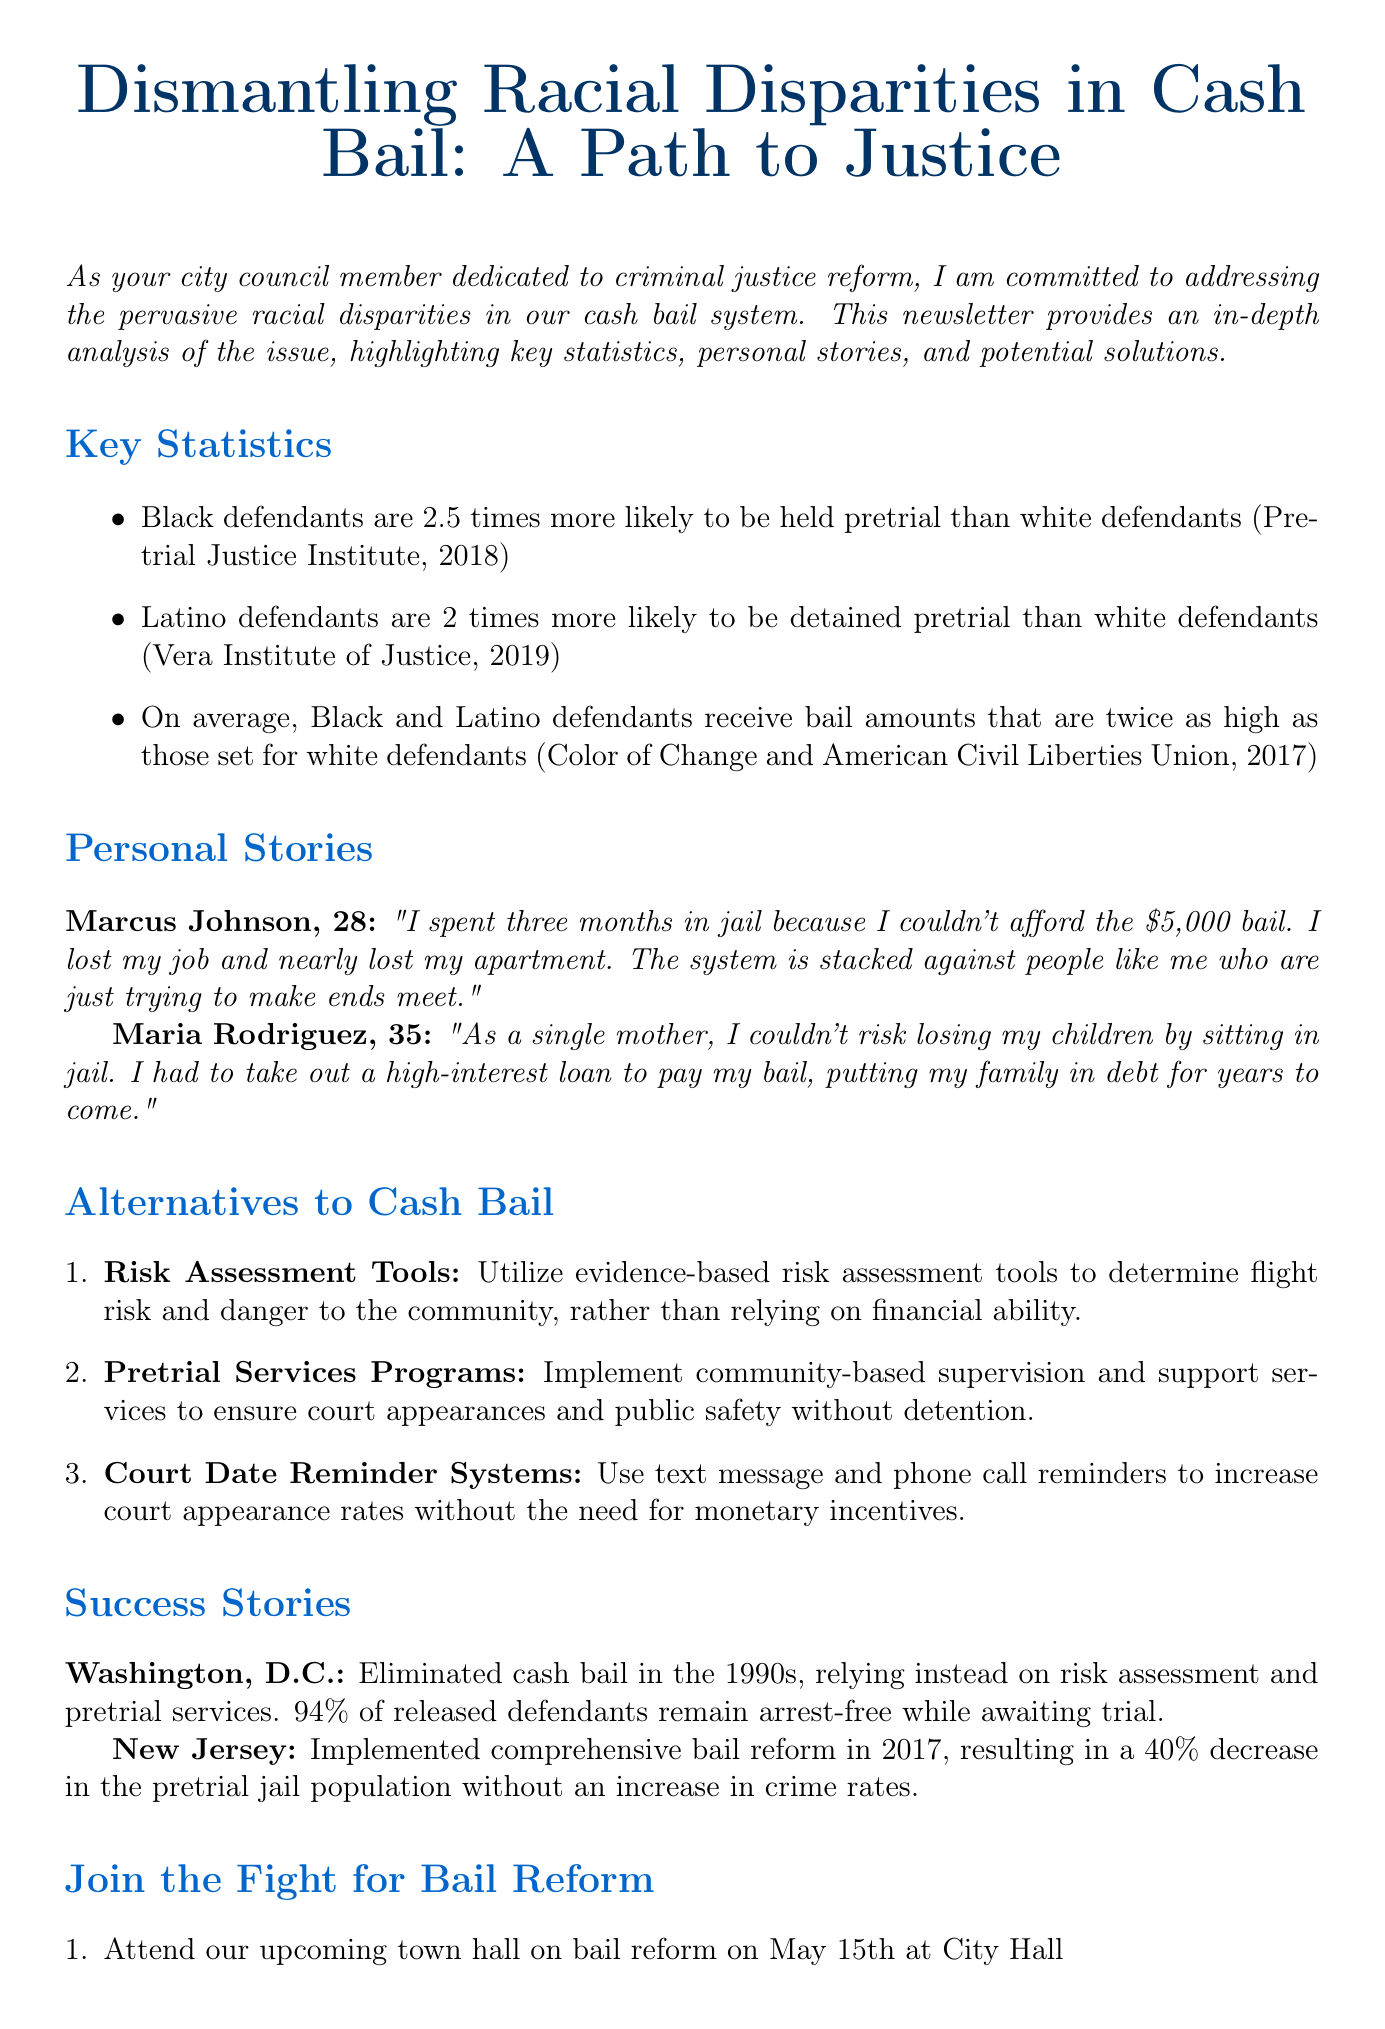What are the average bail amounts set for Black defendants? The average bail amounts for Black defendants is provided in a pie chart showing their bail amount compared to other racial groups.
Answer: 20000 What percentage of released defendants in Washington, D.C. remain arrest-free while awaiting trial? This information is stated in the success story section regarding Washington, D.C.'s bail reform efforts.
Answer: 94% How much more likely are Black defendants to be held pretrial compared to white defendants? The statistic regarding the likelihood of Black defendants being held pretrial compared to white defendants is clearly mentioned in the key statistics.
Answer: 2.5 times What type of system is suggested for increasing court appearance rates? The newsletter outlines a system aimed at increasing court appearance rates in the alternatives to cash bail section.
Answer: Court Date Reminder Systems Who is the quote attributed to that discusses the negative effects of a $5,000 bail? The newsletter includes personal stories that feature quotes from individuals affected by cash bail systems, highlighting their experiences.
Answer: Marcus Johnson 